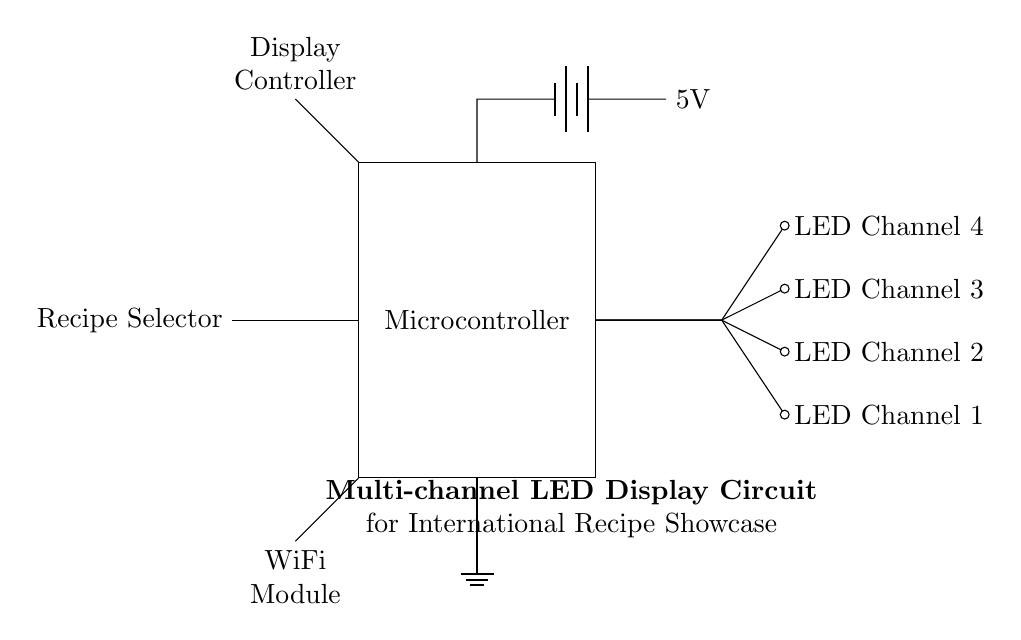What is the main component of the circuit? The main component is the Microcontroller, which is responsible for processing and controlling the LED channels and other peripherals.
Answer: Microcontroller How many LED channels are there? There are four LED channels, as indicated by the nodes labeled LED Channel 1 to LED Channel 4 connected to the microcontroller.
Answer: Four What voltage does the circuit operate at? The circuit operates at a voltage of 5V, as noted next to the battery symbol connected to the microcontroller.
Answer: 5V What is the purpose of the WiFi module in this circuit? The WiFi module allows the microcontroller to connect to internet services, which could be used to retrieve or display international recipes.
Answer: Connectivity What type of power supply is used in this circuit? The power supply used in this circuit is a battery, as symbolized by the battery icon connected to the microcontroller.
Answer: Battery What is the function of the Recipe Selector? The Recipe Selector allows users to choose which recipe to display on the LED channels by sending input to the microcontroller.
Answer: Recipe selection How does the Display Controller relate to the circuit? The Display Controller is responsible for managing the output shown on the LED channels, driven by the microcontroller's signals based on the selected recipe.
Answer: Output management 